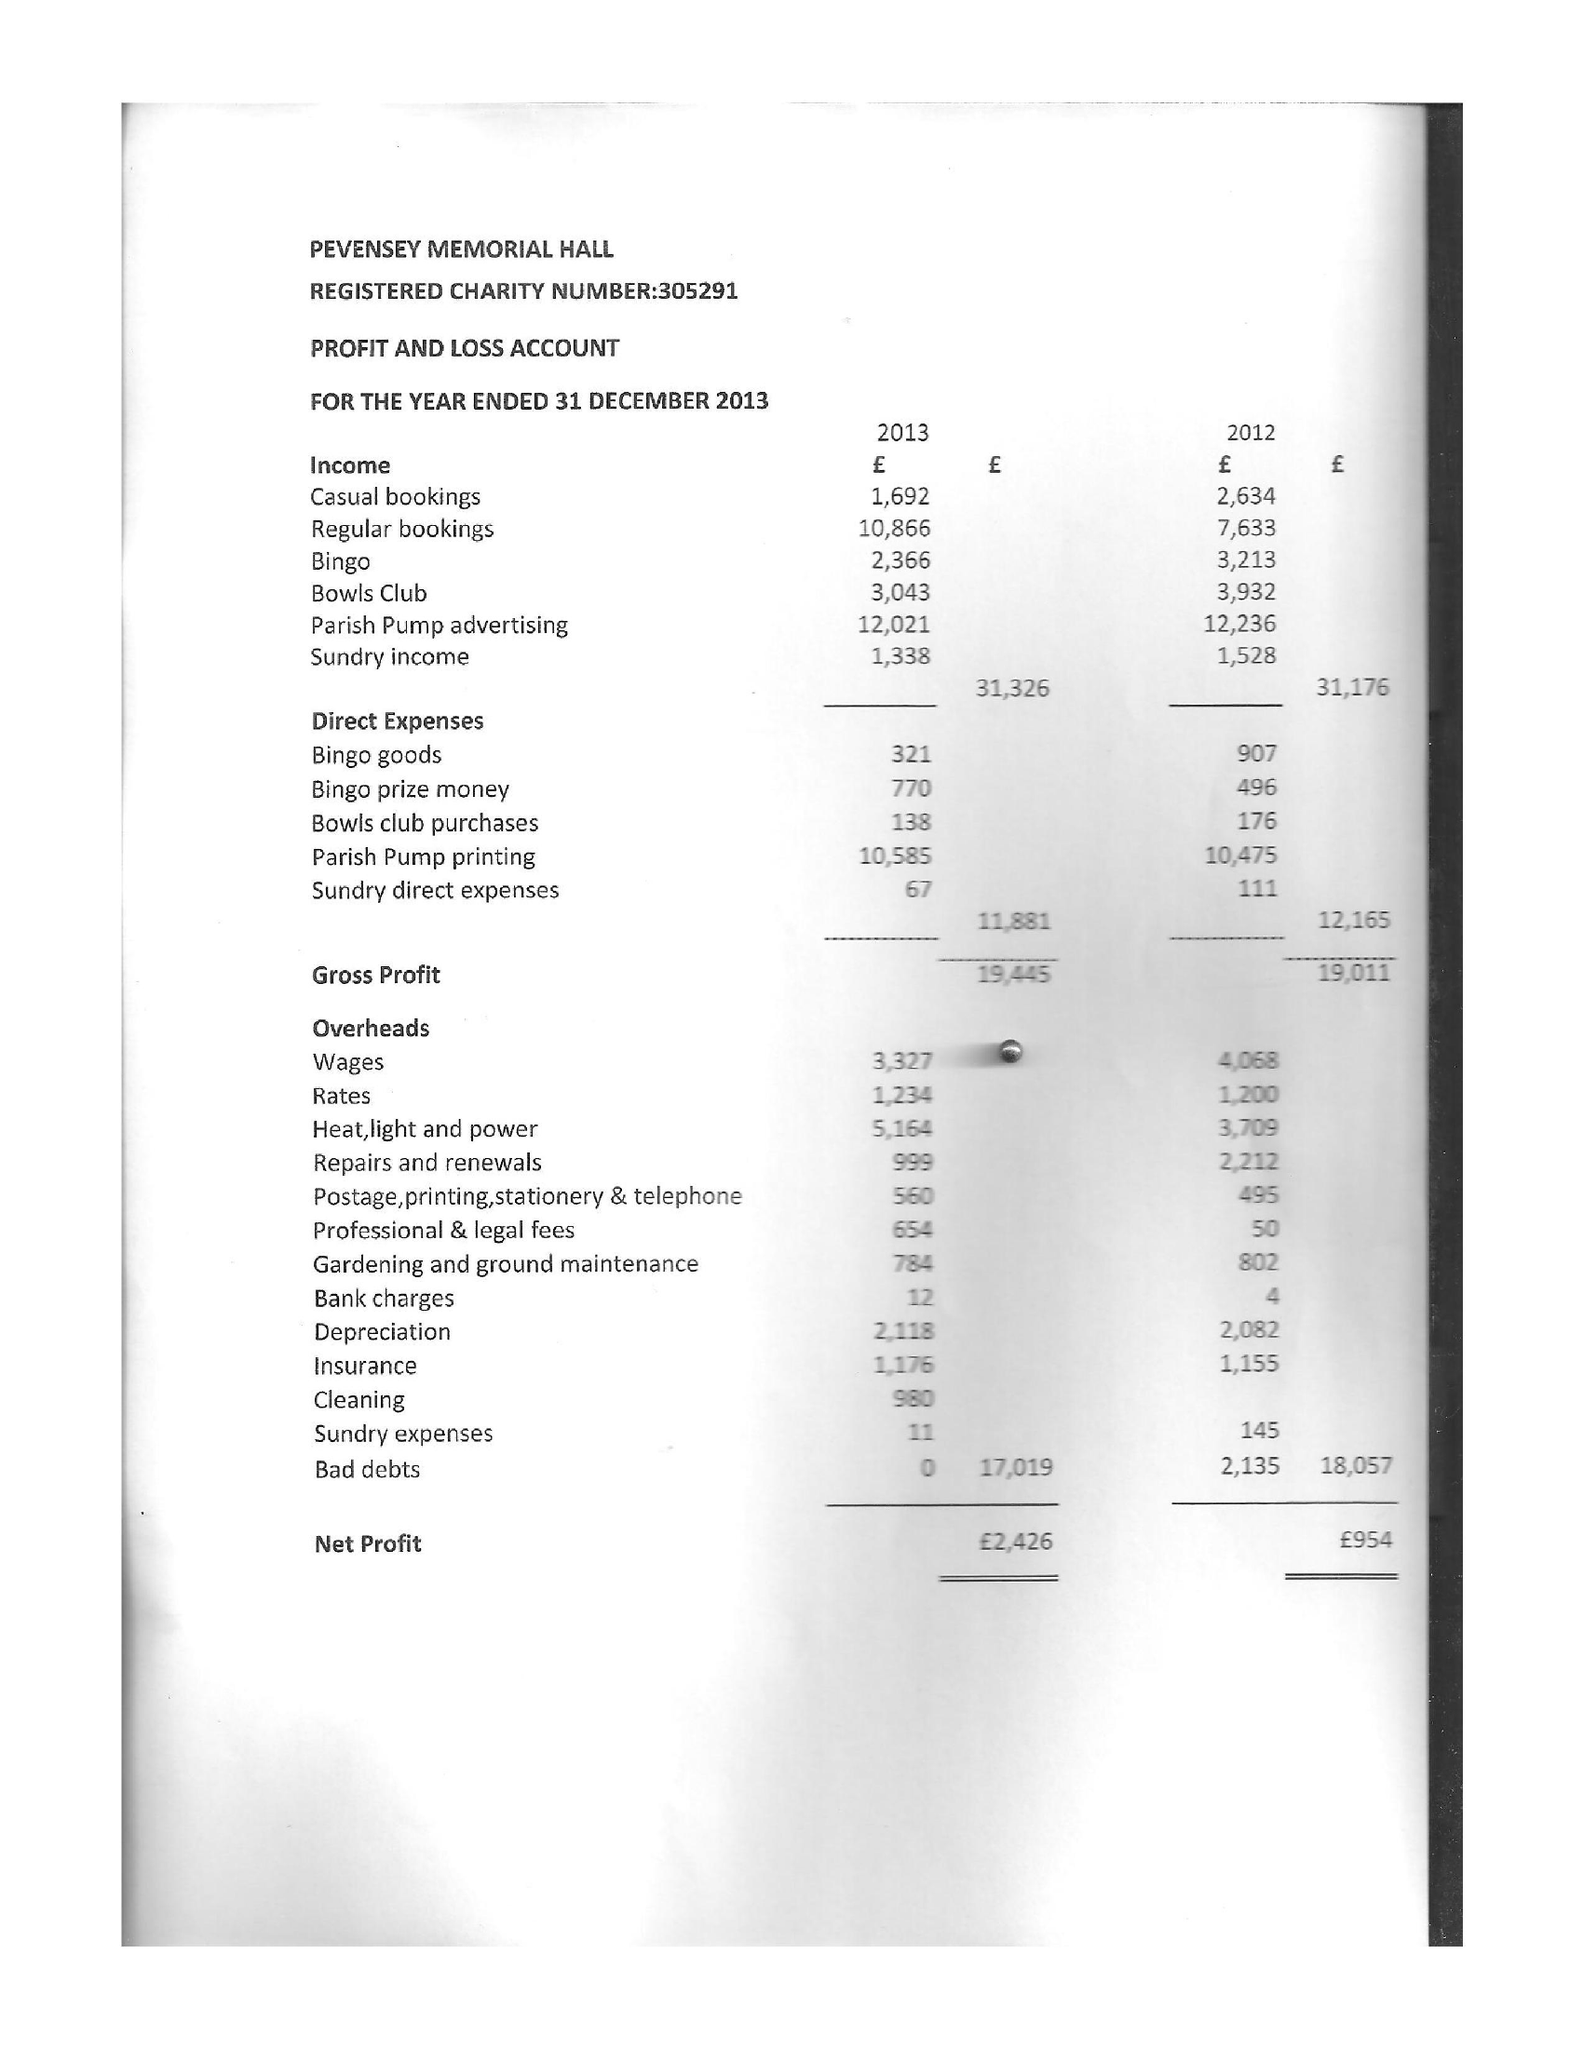What is the value for the report_date?
Answer the question using a single word or phrase. 2013-12-31 